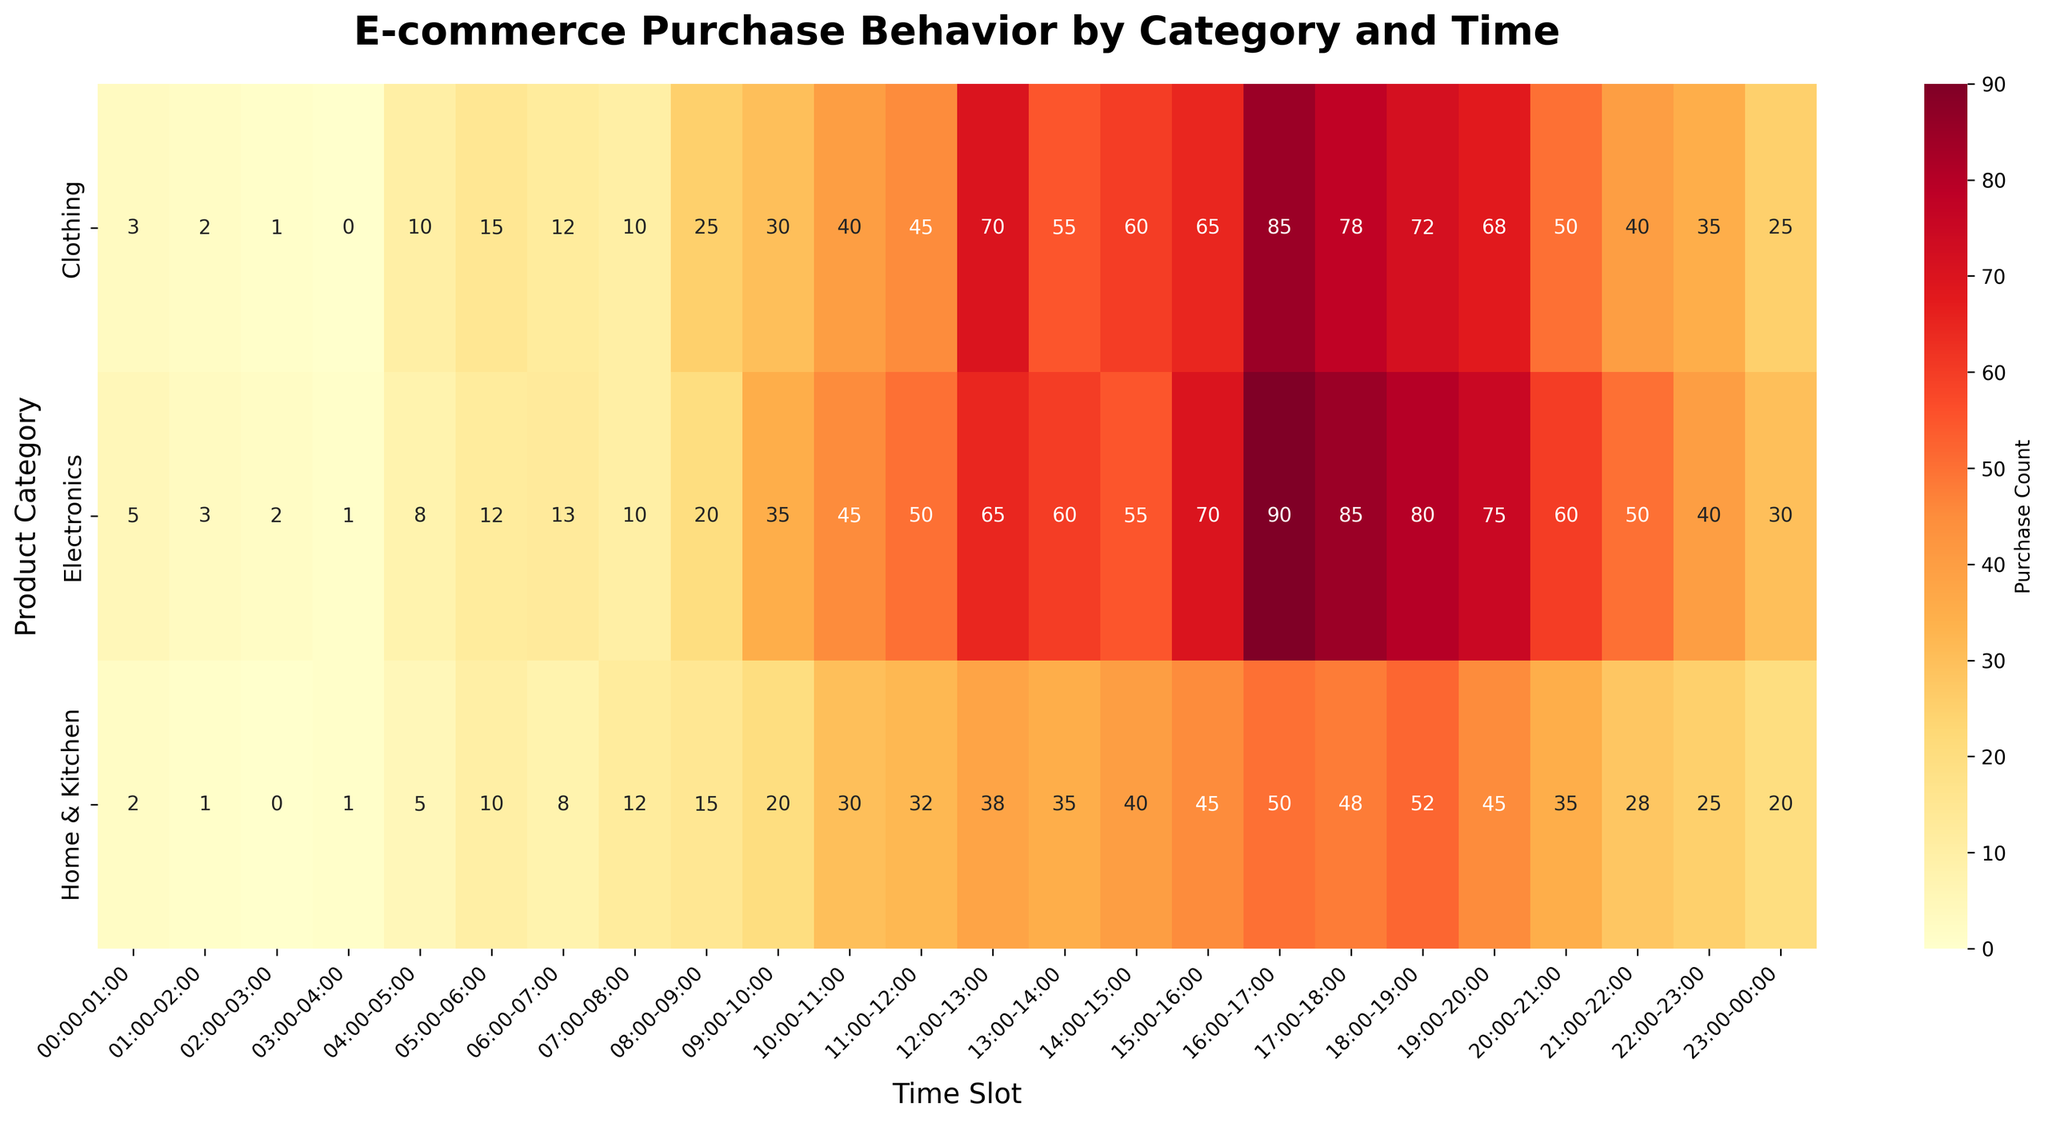What's the title of the heatmap? The title of the heatmap is usually located at the top of the plot. By looking at the heatmap, you can see the title in bold text at the top.
Answer: E-commerce Purchase Behavior by Category and Time What is the color scheme used in the heatmap? The color scheme in a heatmap can often be identified by the range of colors used to depict different values. In this case, the heatmap uses a gradient ranging from yellow to red, which indicates the 'YlOrRd' color map (Yellow-Orange-Red) is used.
Answer: Yellow to Red At which hour is the highest purchase count recorded in the Electronics category? By inspecting the heatmap, find the row for Electronics and look for the hour with the darkest red color, which represents the highest purchase count. The darkest red in Electronics is at 16:00-17:00.
Answer: 16:00-17:00 Between 12:00-13:00, which category has the highest purchase count? Review the column for 12:00-13:00 across all rows (categories) and identify the darkest red color which signifies the highest purchase count. The Clothing category has the darker color in this time slot.
Answer: Clothing What is the total number of purchases in Electronics between 16:00-20:00? Sum the purchase counts in the Electronics category for the time slots 16:00-17:00, 17:00-18:00, 18:00-19:00, 19:00-20:00. The counts are 90, 85, 80, 75 respectively: 90 + 85 + 80 + 75 = 330.
Answer: 330 Which category has more purchases at 10:00-11:00, Clothing or Home & Kitchen? Compare the 10:00-11:00 time slot values for Clothing and Home & Kitchen. Clothing has 40, Home & Kitchen has 30. Clothing has more purchases.
Answer: Clothing By looking at the heatmap, how many categories are displayed in total? Count the total number of rows on the heatmap, which corresponds to the number of categories. The heatmap has three rows for Electronics, Clothing, and Home & Kitchen.
Answer: 3 During which time slot does the Home & Kitchen category experience a notable increase in purchase count relative to the preceding hour? Locate the Home & Kitchen row and look for a significant jump in color intensity (towards red) compared to the preceding time slot. 18:00-19:00 sees an increase from 48 to 52.
Answer: 18:00-19:00 In the Clothing category, what is the difference in purchase count between the peak hour and the lowest hour? Identify the highest purchase count value in the Clothing row (70 at 12:00-13:00) and the lowest (0 at 03:00-04:00). Calculate the difference: 70 - 0 = 70.
Answer: 70 Which time slot shows a decreasing trend of purchase counts in all three categories? Look for a column where values decrease sequentially as you move down the rows. For 05:00-06:00, Electronics (12), Clothing (15), and Home & Kitchen (10) show a decreasing trend.
Answer: 05:00-06:00 